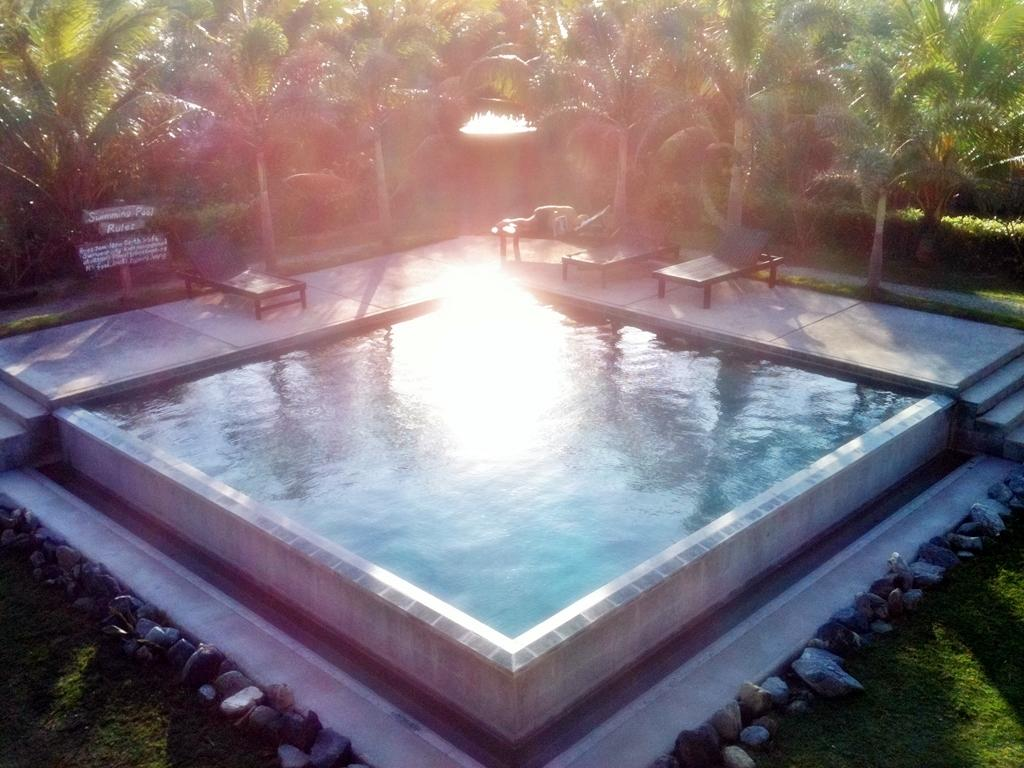What type of natural elements can be seen in the image? There are rocks and grass in the image. What man-made structure is present in the image? There is a swimming pool in the image. Are there any seating options near the swimming pool? Yes, there are swimming pool benches in the image. What else can be seen in the image besides the swimming pool and benches? There are boards attached to poles and trees in the image. Can you tell me how many strangers are interacting with the boy in the image? There is no boy or stranger present in the image. 